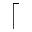Convert formula to latex. <formula><loc_0><loc_0><loc_500><loc_500>\lceil</formula> 